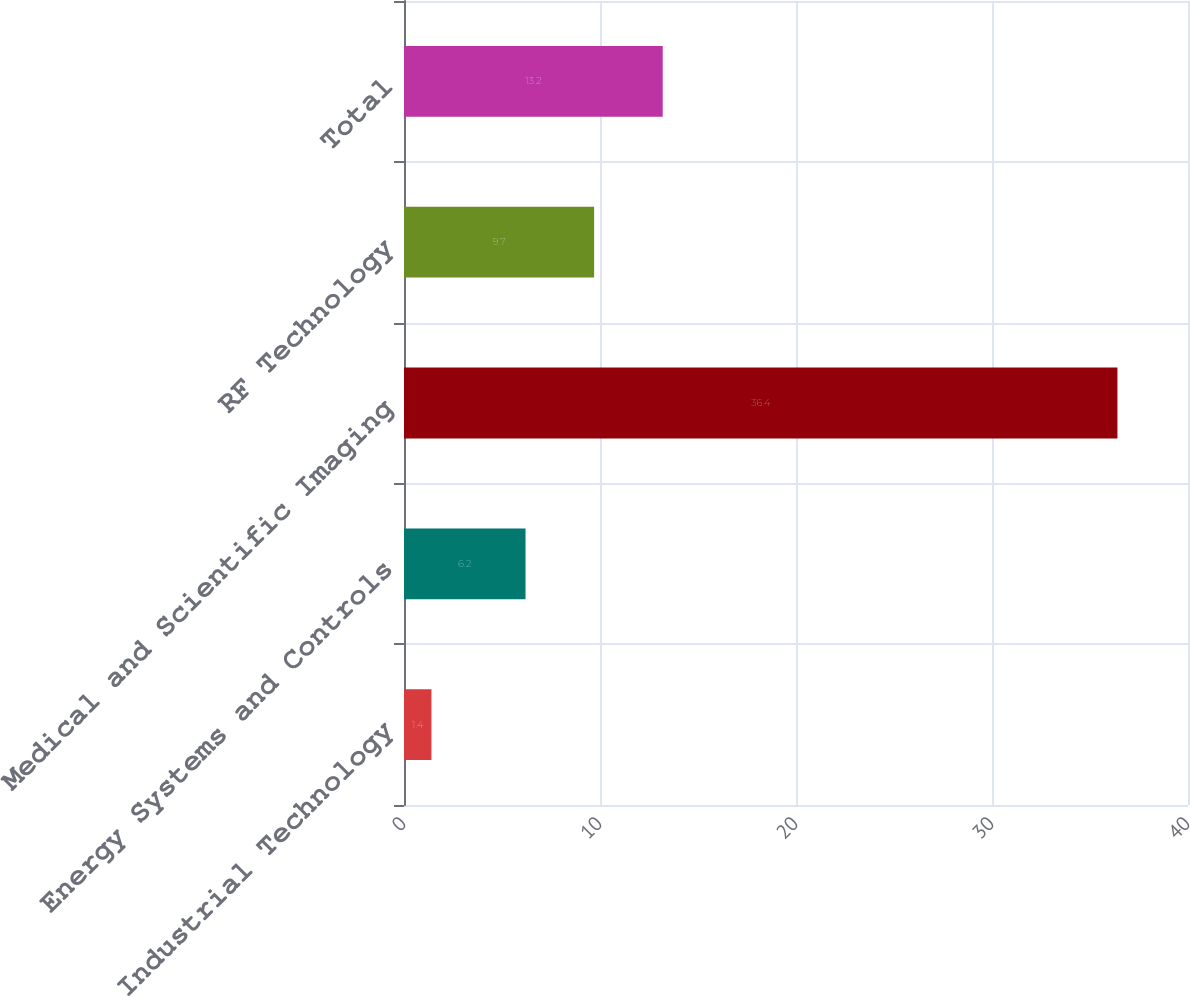<chart> <loc_0><loc_0><loc_500><loc_500><bar_chart><fcel>Industrial Technology<fcel>Energy Systems and Controls<fcel>Medical and Scientific Imaging<fcel>RF Technology<fcel>Total<nl><fcel>1.4<fcel>6.2<fcel>36.4<fcel>9.7<fcel>13.2<nl></chart> 